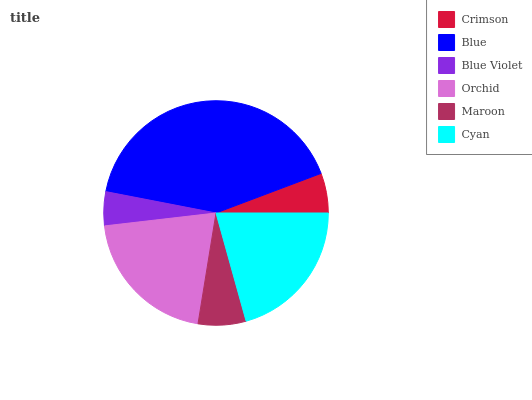Is Blue Violet the minimum?
Answer yes or no. Yes. Is Blue the maximum?
Answer yes or no. Yes. Is Blue the minimum?
Answer yes or no. No. Is Blue Violet the maximum?
Answer yes or no. No. Is Blue greater than Blue Violet?
Answer yes or no. Yes. Is Blue Violet less than Blue?
Answer yes or no. Yes. Is Blue Violet greater than Blue?
Answer yes or no. No. Is Blue less than Blue Violet?
Answer yes or no. No. Is Orchid the high median?
Answer yes or no. Yes. Is Maroon the low median?
Answer yes or no. Yes. Is Cyan the high median?
Answer yes or no. No. Is Orchid the low median?
Answer yes or no. No. 